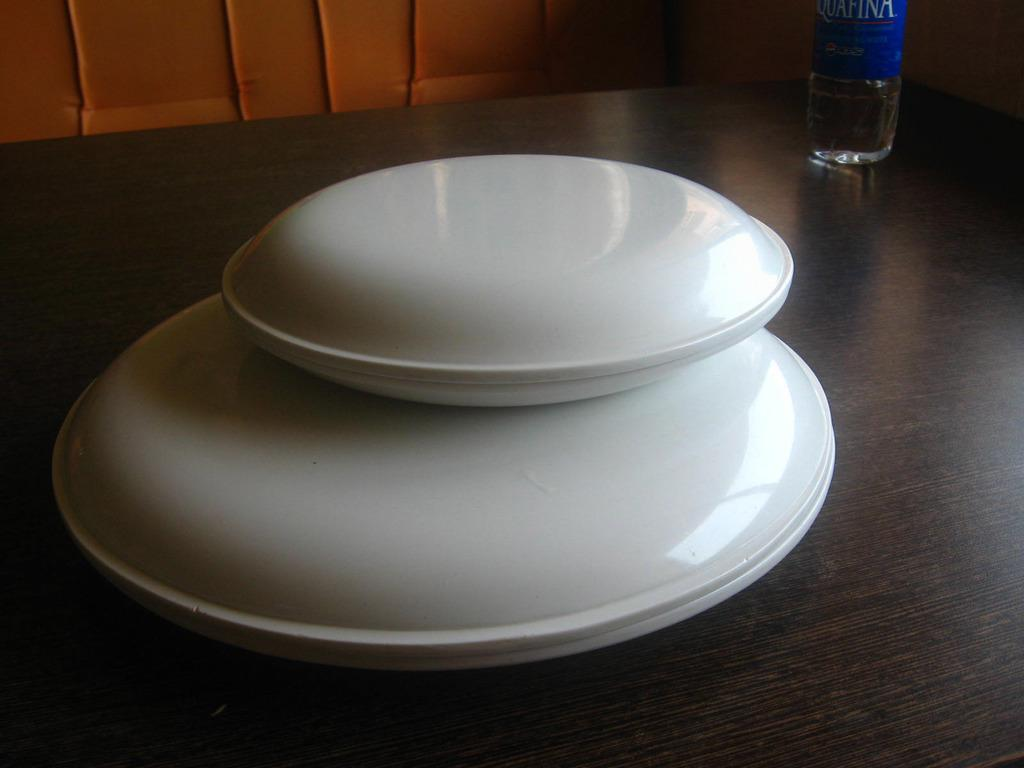What type of furniture is in the image? There is a table in the image. What object is placed on the table? A bottle is present on the table. How many plates are on the table? There are four plates on the table. What type of tub is visible in the image? There is no tub present in the image. 